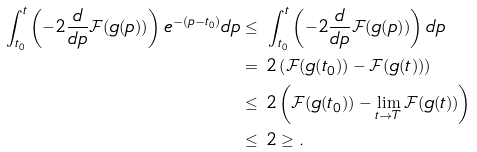<formula> <loc_0><loc_0><loc_500><loc_500>\int _ { t _ { 0 } } ^ { t } \left ( - 2 \frac { d } { d p } \mathcal { F } ( g ( p ) ) \right ) e ^ { - ( p - t _ { 0 } ) } d p \leq & \ \int _ { t _ { 0 } } ^ { t } \left ( - 2 \frac { d } { d p } \mathcal { F } ( g ( p ) ) \right ) d p \\ = & \ 2 \left ( \mathcal { F } ( g ( t _ { 0 } ) ) - \mathcal { F } ( g ( t ) ) \right ) \\ \leq & \ 2 \left ( \mathcal { F } ( g ( t _ { 0 } ) ) - \lim _ { t \to T } \mathcal { F } ( g ( t ) ) \right ) \\ \leq & \ 2 \geq .</formula> 